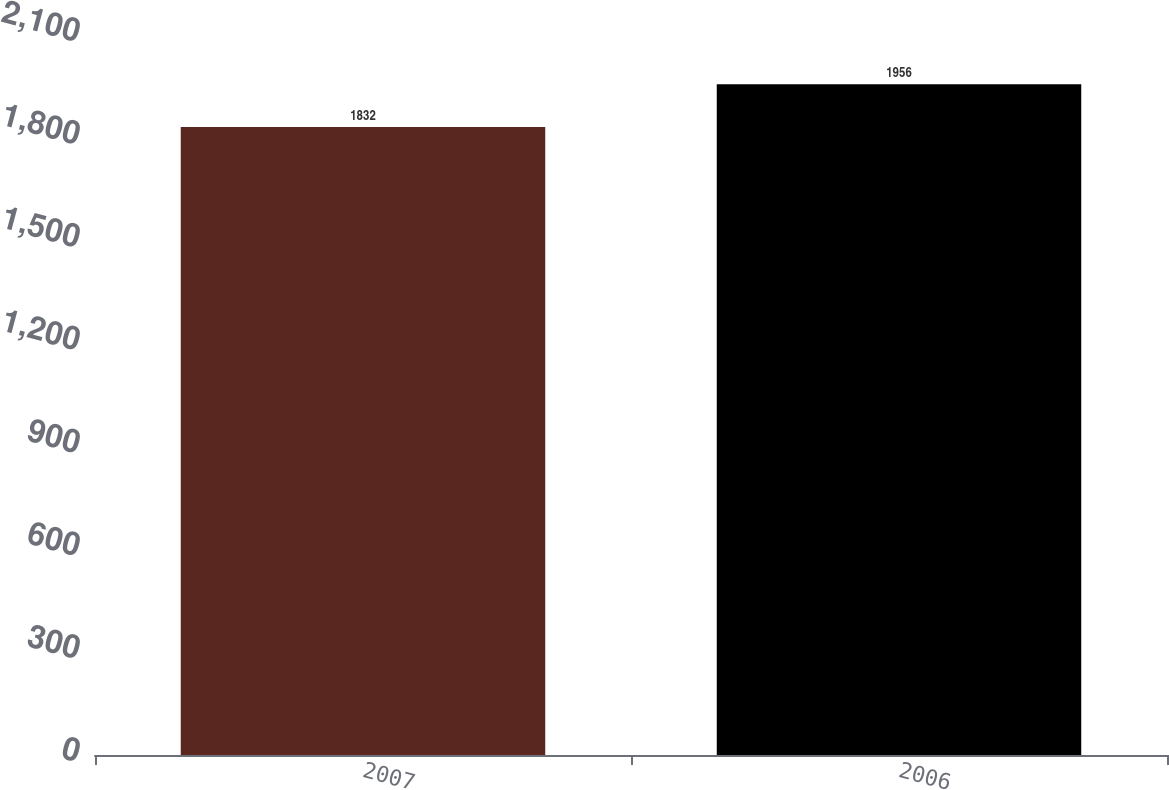Convert chart to OTSL. <chart><loc_0><loc_0><loc_500><loc_500><bar_chart><fcel>2007<fcel>2006<nl><fcel>1832<fcel>1956<nl></chart> 